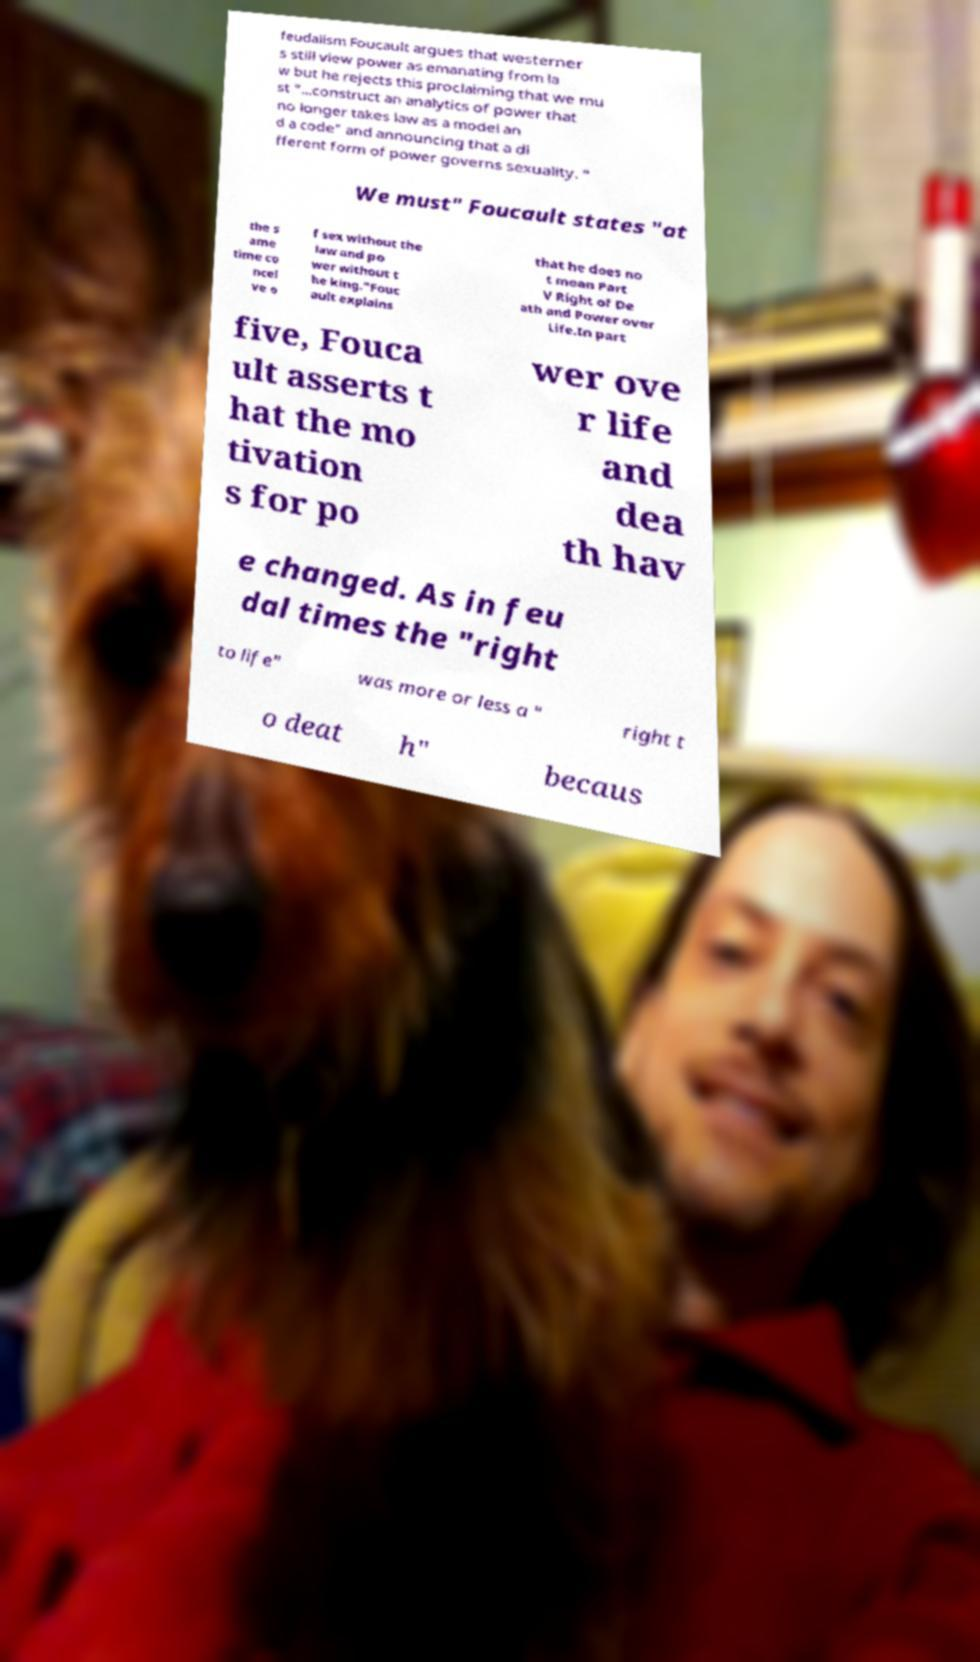Could you assist in decoding the text presented in this image and type it out clearly? feudalism Foucault argues that westerner s still view power as emanating from la w but he rejects this proclaiming that we mu st "...construct an analytics of power that no longer takes law as a model an d a code" and announcing that a di fferent form of power governs sexuality. " We must" Foucault states "at the s ame time co ncei ve o f sex without the law and po wer without t he king."Fouc ault explains that he does no t mean Part V Right of De ath and Power over Life.In part five, Fouca ult asserts t hat the mo tivation s for po wer ove r life and dea th hav e changed. As in feu dal times the "right to life" was more or less a " right t o deat h" becaus 